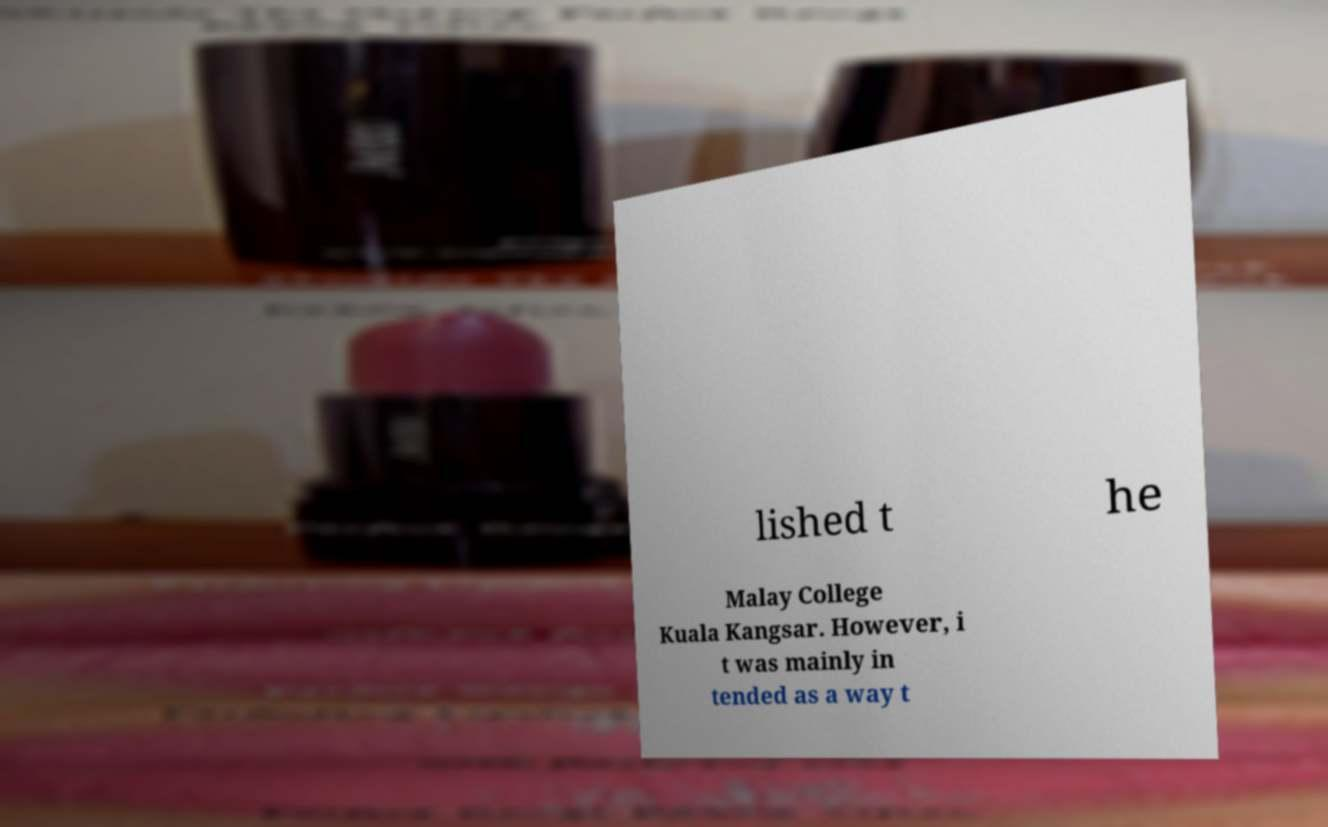Can you read and provide the text displayed in the image?This photo seems to have some interesting text. Can you extract and type it out for me? lished t he Malay College Kuala Kangsar. However, i t was mainly in tended as a way t 